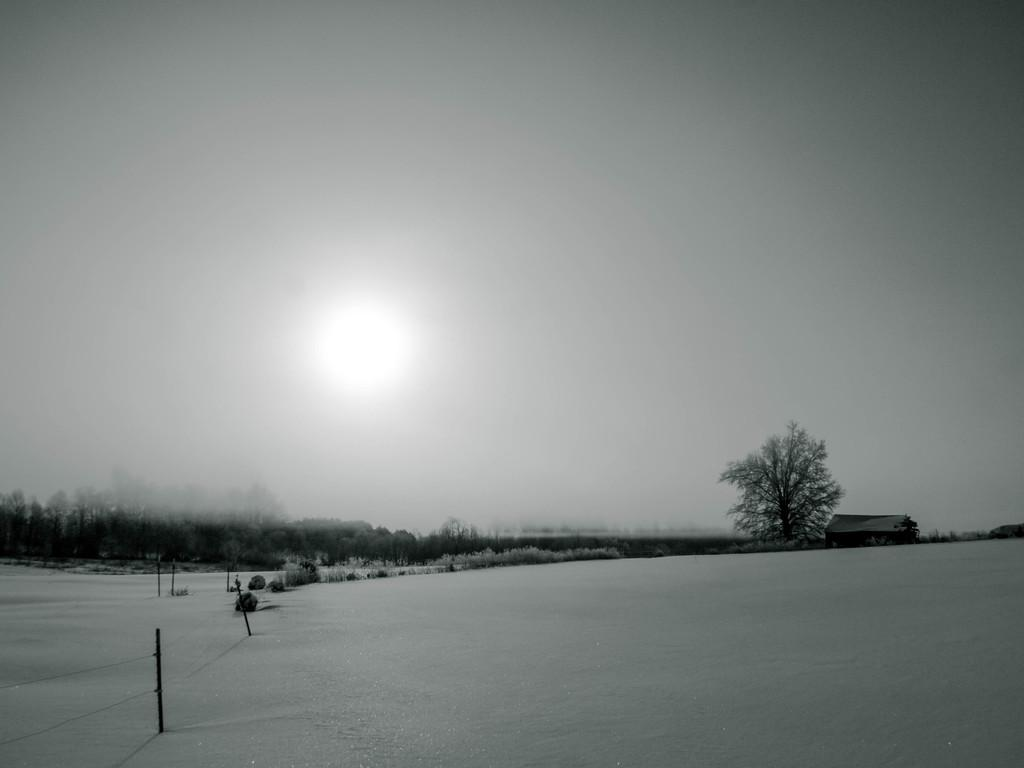What is the color scheme of the image? The image is black and white. What can be seen on the left side of the image? There is fencing on the ground on the left side. What is visible in the background of the image? There are trees, plants, a house, and the sky visible in the background. How many mittens are hanging on the fence in the image? There are no mittens present in the image; it features a black and white scene with fencing, trees, plants, a house, and the sky. 